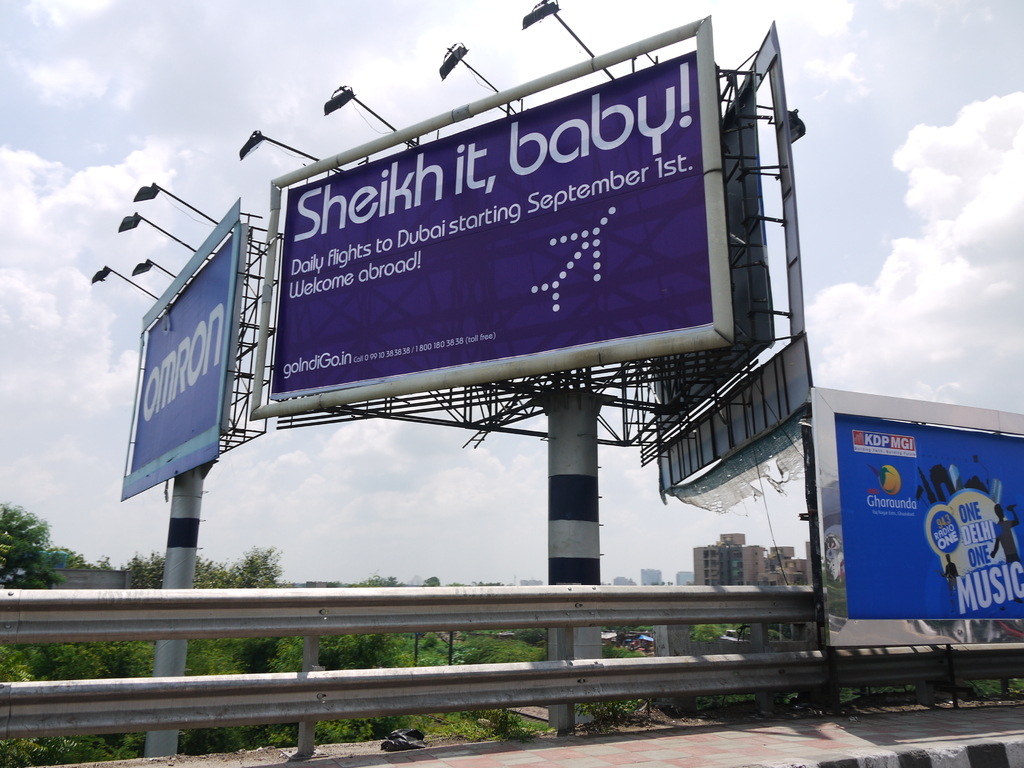Provide a one-sentence caption for the provided image.
Reference OCR token: baby!, 1st., Sheikh, to, Dubaistarting, it,, September, Daily, fights, Wekome, abroad!, golndiGa.inco, KDPMGI, Gharaunda, ONE, MUSIC A purple billboard advertising for Dubai flights tells viewers to "Sheik it, baby!". 